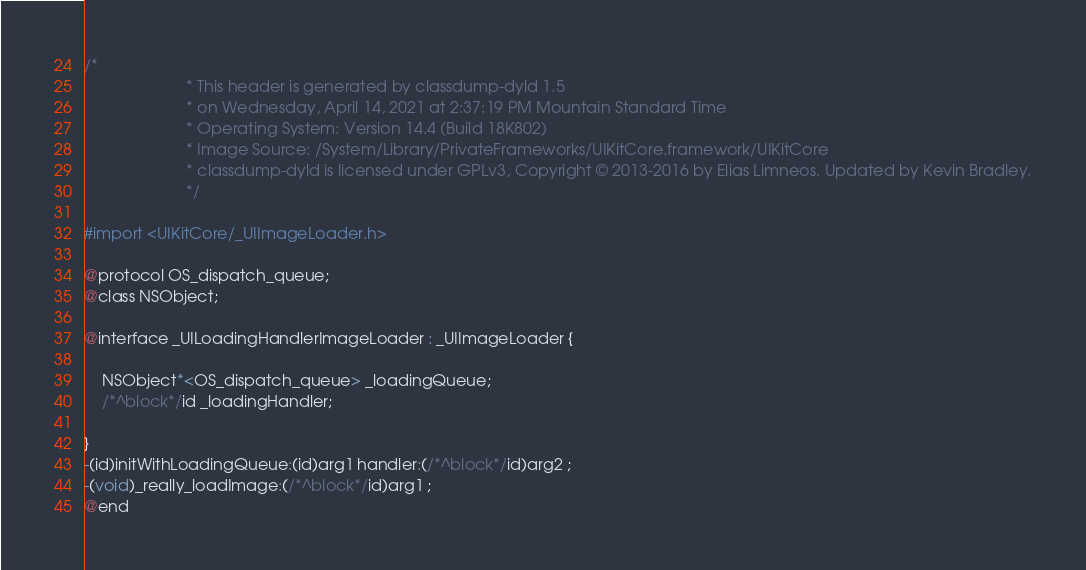Convert code to text. <code><loc_0><loc_0><loc_500><loc_500><_C_>/*
                       * This header is generated by classdump-dyld 1.5
                       * on Wednesday, April 14, 2021 at 2:37:19 PM Mountain Standard Time
                       * Operating System: Version 14.4 (Build 18K802)
                       * Image Source: /System/Library/PrivateFrameworks/UIKitCore.framework/UIKitCore
                       * classdump-dyld is licensed under GPLv3, Copyright © 2013-2016 by Elias Limneos. Updated by Kevin Bradley.
                       */

#import <UIKitCore/_UIImageLoader.h>

@protocol OS_dispatch_queue;
@class NSObject;

@interface _UILoadingHandlerImageLoader : _UIImageLoader {

	NSObject*<OS_dispatch_queue> _loadingQueue;
	/*^block*/id _loadingHandler;

}
-(id)initWithLoadingQueue:(id)arg1 handler:(/*^block*/id)arg2 ;
-(void)_really_loadImage:(/*^block*/id)arg1 ;
@end

</code> 